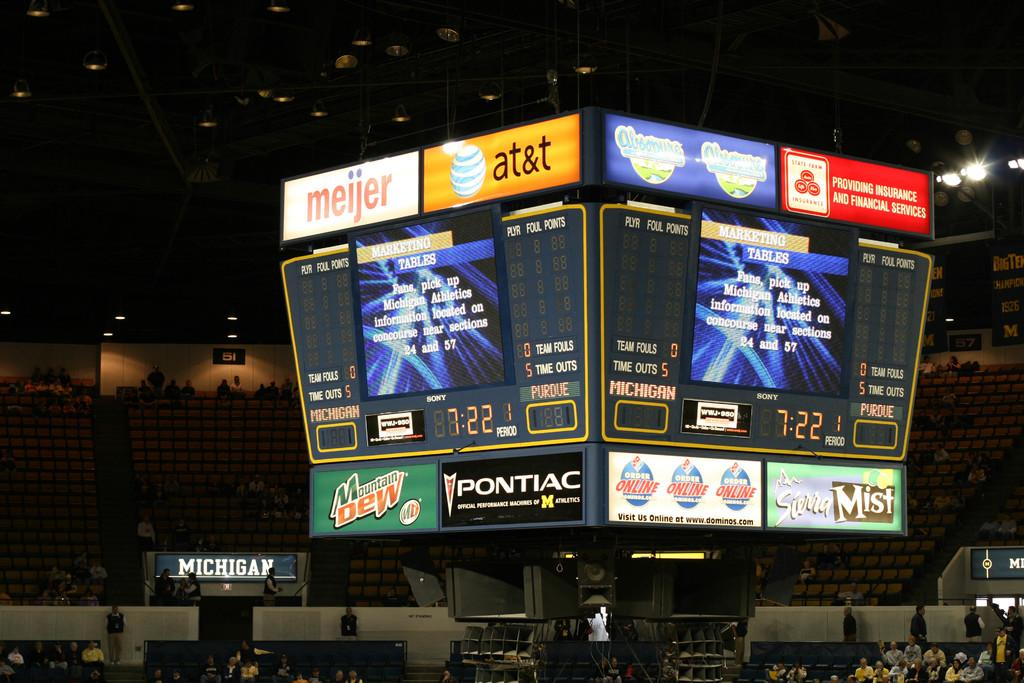<image>
Summarize the visual content of the image. A jumbotron with ads on it such as Moutain Dew and at&t 